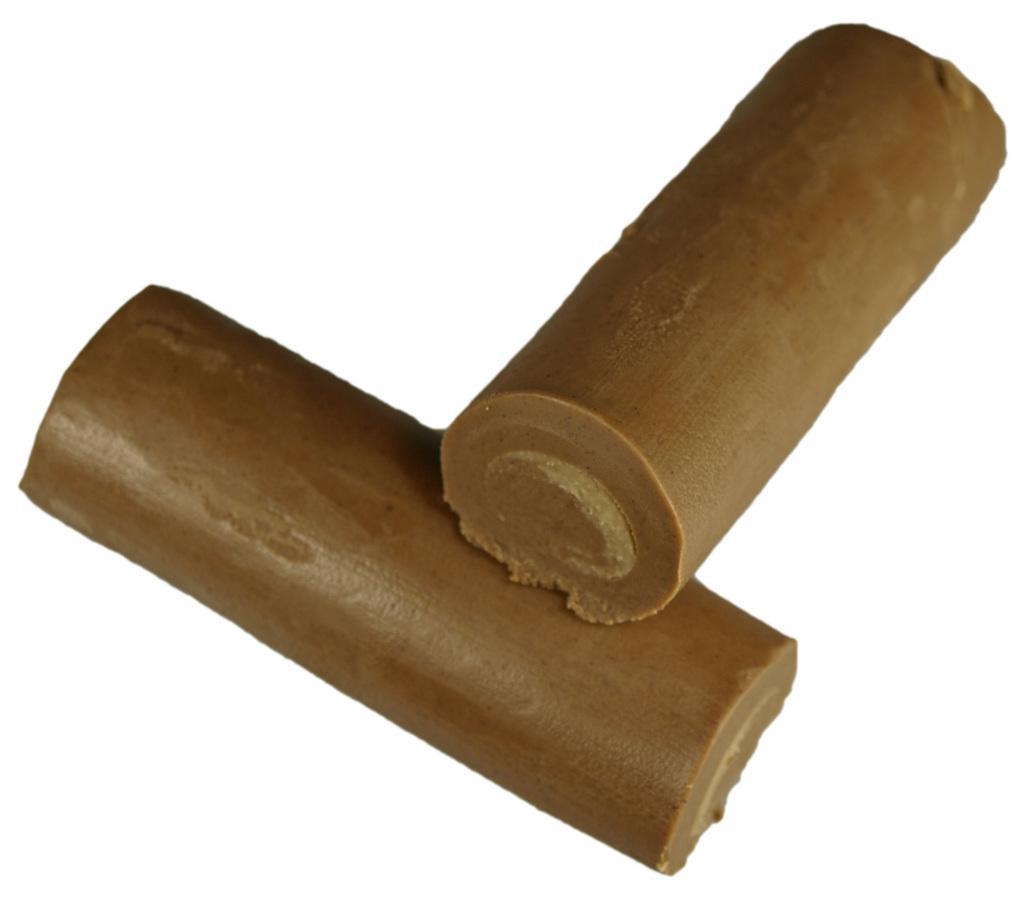In one or two sentences, can you explain what this image depicts? In this picture I can see couple of chocolate pieces and I can see a white color background. 